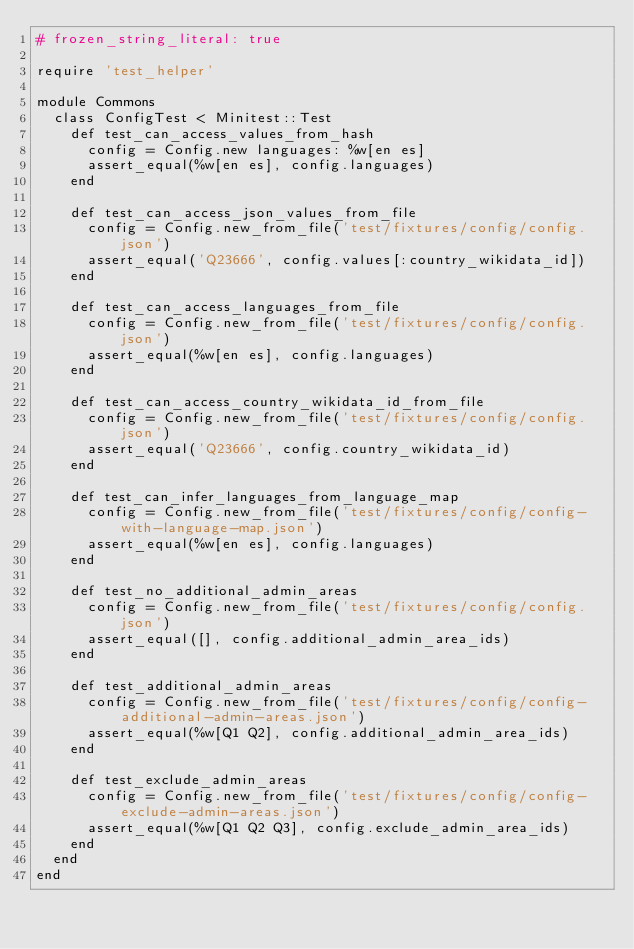Convert code to text. <code><loc_0><loc_0><loc_500><loc_500><_Ruby_># frozen_string_literal: true

require 'test_helper'

module Commons
  class ConfigTest < Minitest::Test
    def test_can_access_values_from_hash
      config = Config.new languages: %w[en es]
      assert_equal(%w[en es], config.languages)
    end

    def test_can_access_json_values_from_file
      config = Config.new_from_file('test/fixtures/config/config.json')
      assert_equal('Q23666', config.values[:country_wikidata_id])
    end

    def test_can_access_languages_from_file
      config = Config.new_from_file('test/fixtures/config/config.json')
      assert_equal(%w[en es], config.languages)
    end

    def test_can_access_country_wikidata_id_from_file
      config = Config.new_from_file('test/fixtures/config/config.json')
      assert_equal('Q23666', config.country_wikidata_id)
    end

    def test_can_infer_languages_from_language_map
      config = Config.new_from_file('test/fixtures/config/config-with-language-map.json')
      assert_equal(%w[en es], config.languages)
    end

    def test_no_additional_admin_areas
      config = Config.new_from_file('test/fixtures/config/config.json')
      assert_equal([], config.additional_admin_area_ids)
    end

    def test_additional_admin_areas
      config = Config.new_from_file('test/fixtures/config/config-additional-admin-areas.json')
      assert_equal(%w[Q1 Q2], config.additional_admin_area_ids)
    end

    def test_exclude_admin_areas
      config = Config.new_from_file('test/fixtures/config/config-exclude-admin-areas.json')
      assert_equal(%w[Q1 Q2 Q3], config.exclude_admin_area_ids)
    end
  end
end
</code> 